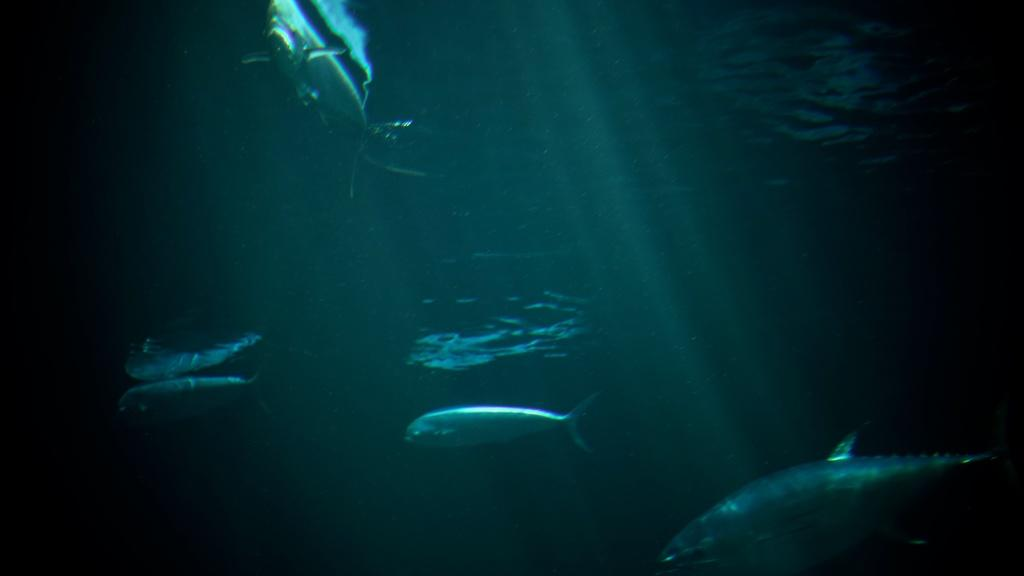What type of animals can be seen in the image? There are fishes in the image. Where are the fishes located? The fishes are in the water. What type of stove is visible in the image? There is no stove present in the image; it features fishes in the water. What instrument is being played by the fishes in the image? There are no instruments or fish playing instruments in the image. 